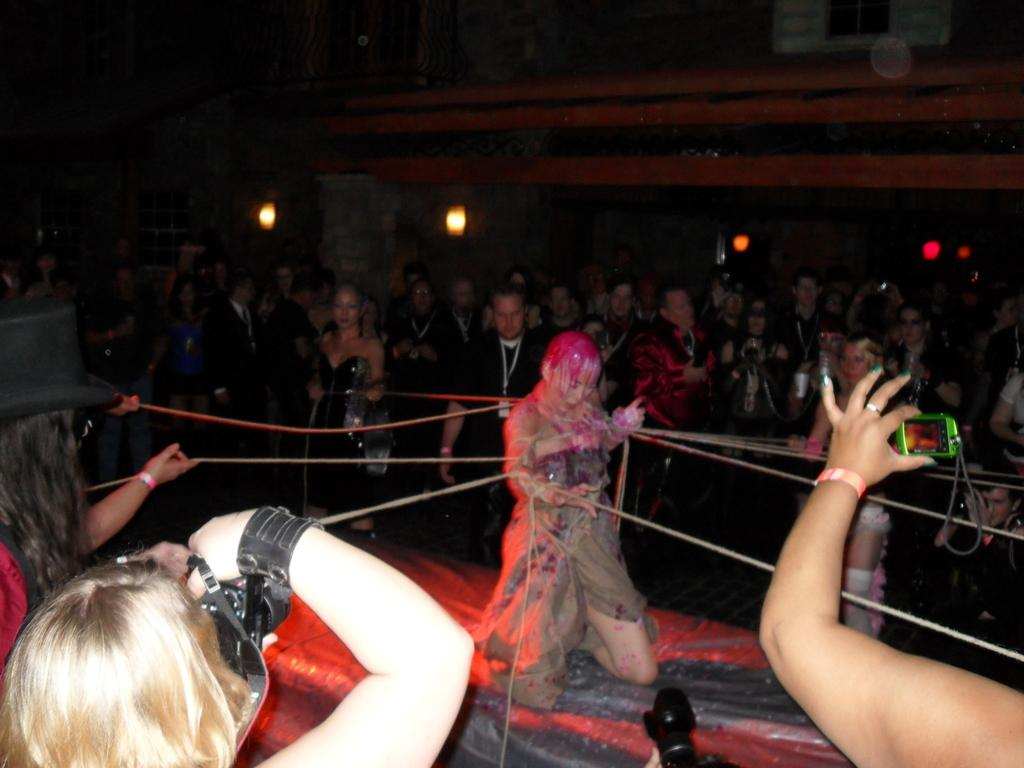Who is the main subject in the image? There is a lady in the image. What is the lady doing in the image? The lady is holding ropes in the image. Are there any other people holding ropes in the image? Yes, there are people holding ropes in the image. What are some people doing with a camera in the image? Some people are taking pictures with a camera in the image. What are the people standing and watching doing in the image? The people standing and watching are observing the scene in the image. What type of rings are being exchanged in the image? There are no rings being exchanged in the image; the lady and other people are holding ropes. Is there a battle taking place in the image? No, there is no battle depicted in the image; people are holding ropes and taking pictures. 